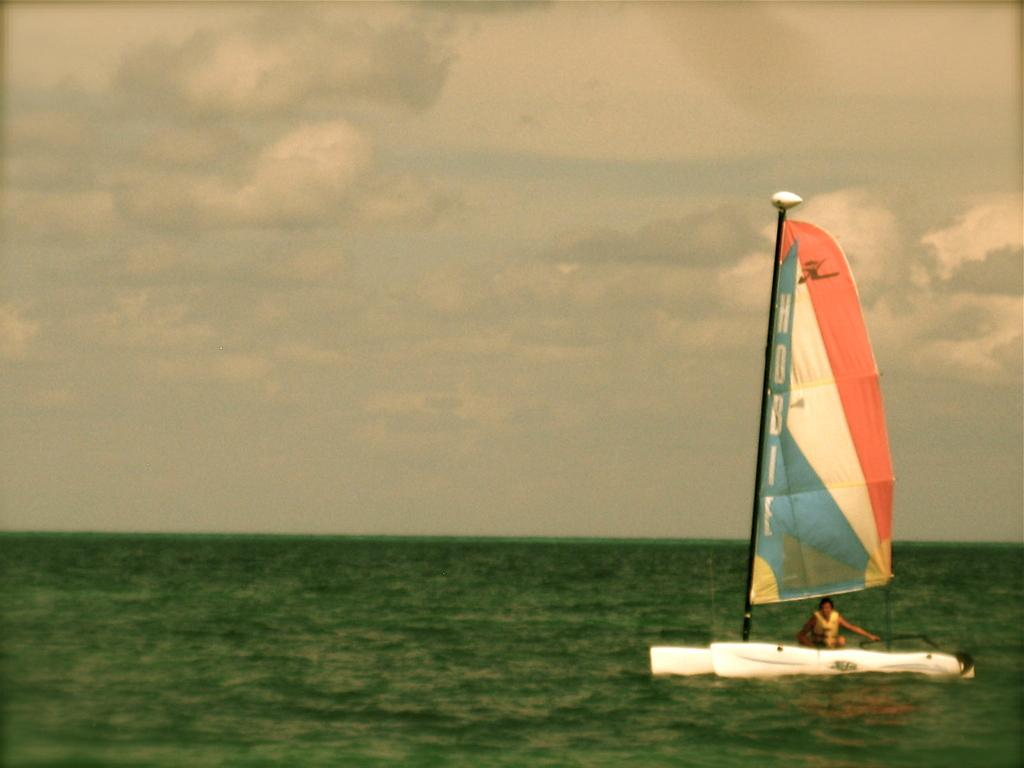What is the person in the image doing? The person is sitting in a sailboat in the image. What is the sailboat doing in the image? The sailboat is floating on the water. Where is the water located in the image? The water is on the right side of the image. What can be seen in the background of the image? The sky is visible in the background of the image. What is the condition of the sky in the image? The sky appears to be cloudy. What type of wax is being used to maintain the sailboat in the image? There is no mention of wax or any maintenance activity in the image; it simply shows a person sitting in a sailboat floating on the water. 